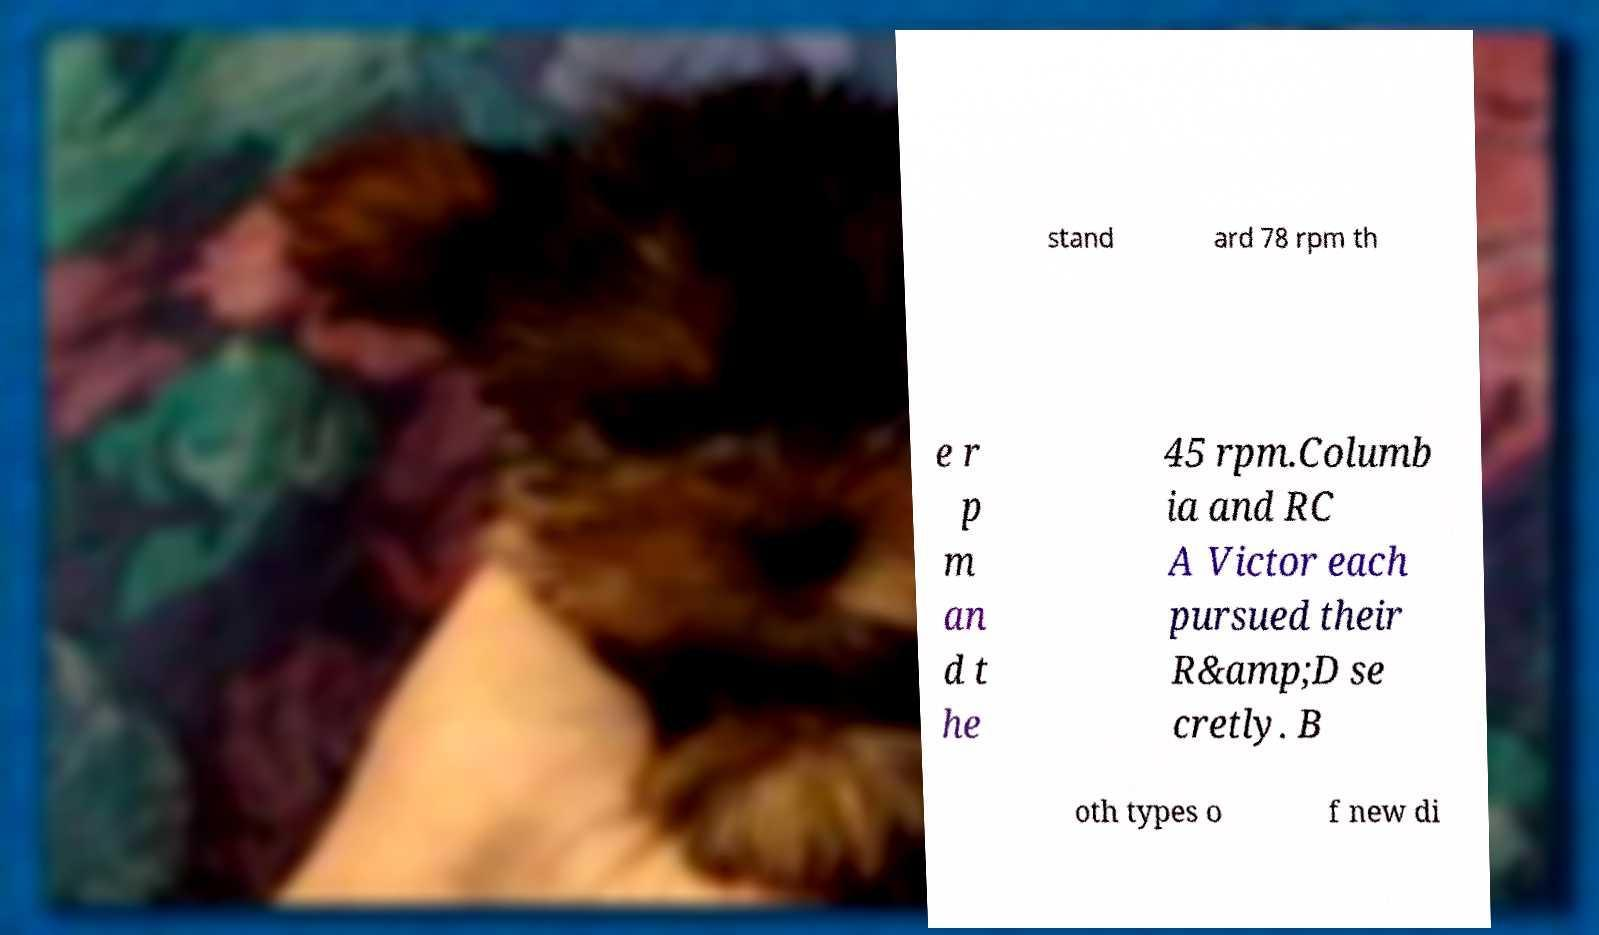For documentation purposes, I need the text within this image transcribed. Could you provide that? stand ard 78 rpm th e r p m an d t he 45 rpm.Columb ia and RC A Victor each pursued their R&amp;D se cretly. B oth types o f new di 